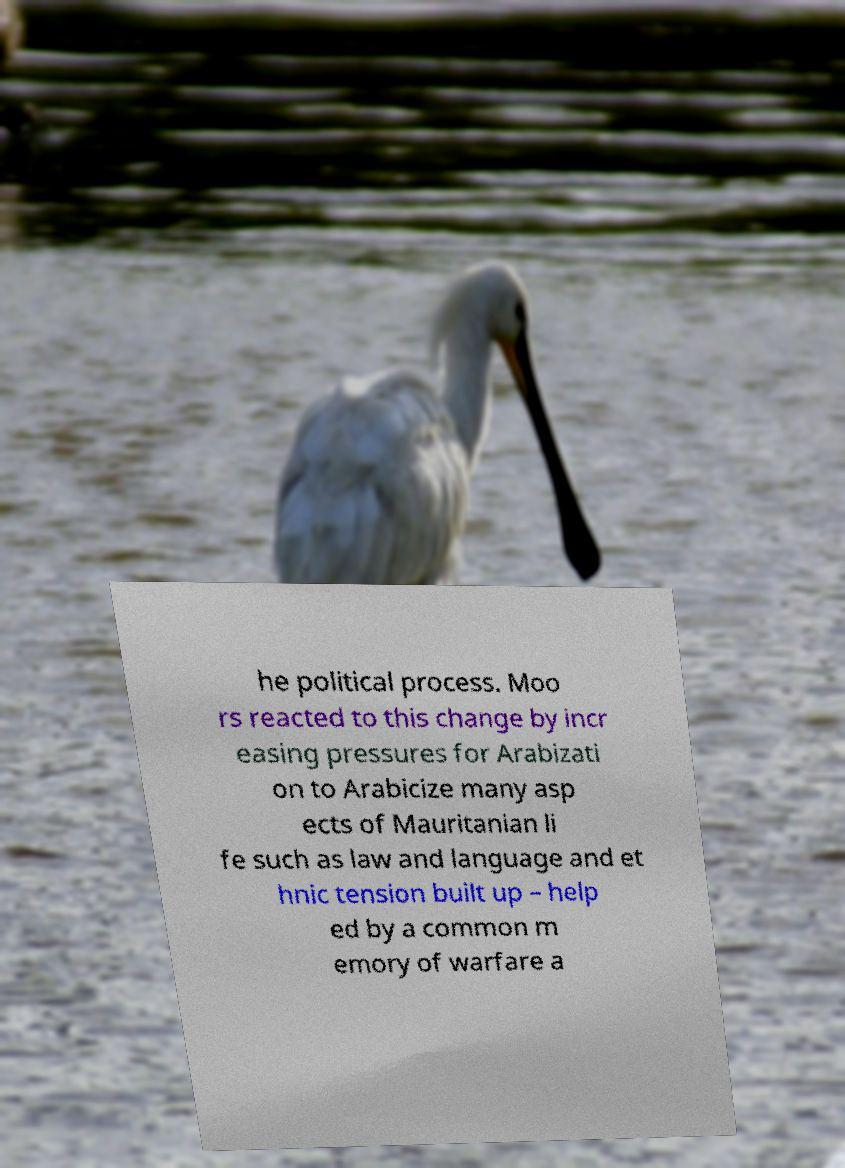I need the written content from this picture converted into text. Can you do that? he political process. Moo rs reacted to this change by incr easing pressures for Arabizati on to Arabicize many asp ects of Mauritanian li fe such as law and language and et hnic tension built up – help ed by a common m emory of warfare a 